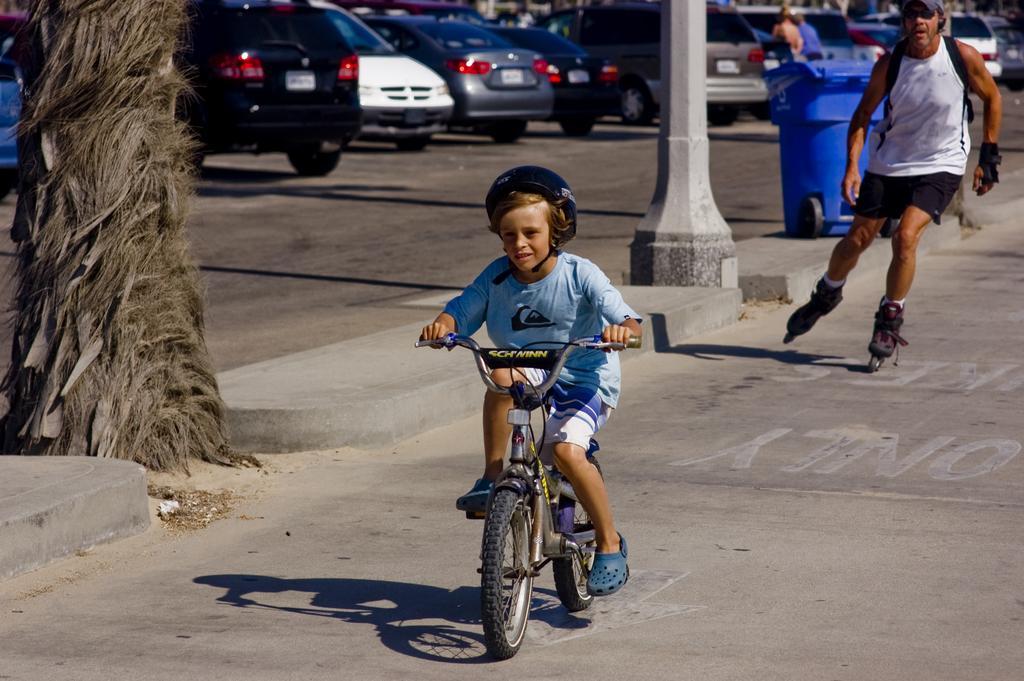Please provide a concise description of this image. In this image i can see a kid riding a bicycle. In the background i can see few vehicles, a person skating and a dust bin. 